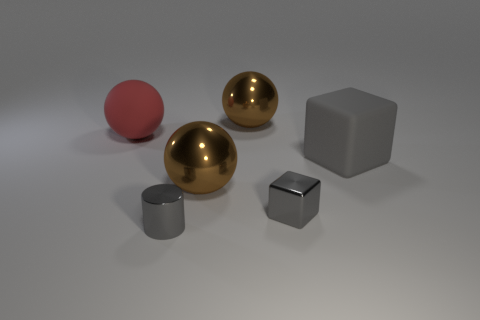What number of blocks are either gray metal things or brown objects?
Make the answer very short. 1. What material is the cube right of the small gray shiny block?
Keep it short and to the point. Rubber. There is a metallic cylinder that is the same color as the big rubber block; what is its size?
Your response must be concise. Small. Do the large ball behind the big red ball and the small thing behind the small cylinder have the same color?
Your answer should be very brief. No. How many objects are small gray shiny things or brown metal balls?
Provide a short and direct response. 4. What number of other objects are there of the same shape as the large gray rubber object?
Make the answer very short. 1. Is the brown thing that is behind the big red thing made of the same material as the tiny cylinder that is in front of the red rubber object?
Give a very brief answer. Yes. What shape is the big object that is to the right of the small shiny cylinder and behind the big block?
Offer a very short reply. Sphere. Are there any other things that are made of the same material as the large block?
Your answer should be very brief. Yes. What material is the large object that is in front of the red rubber thing and to the left of the metallic block?
Your response must be concise. Metal. 